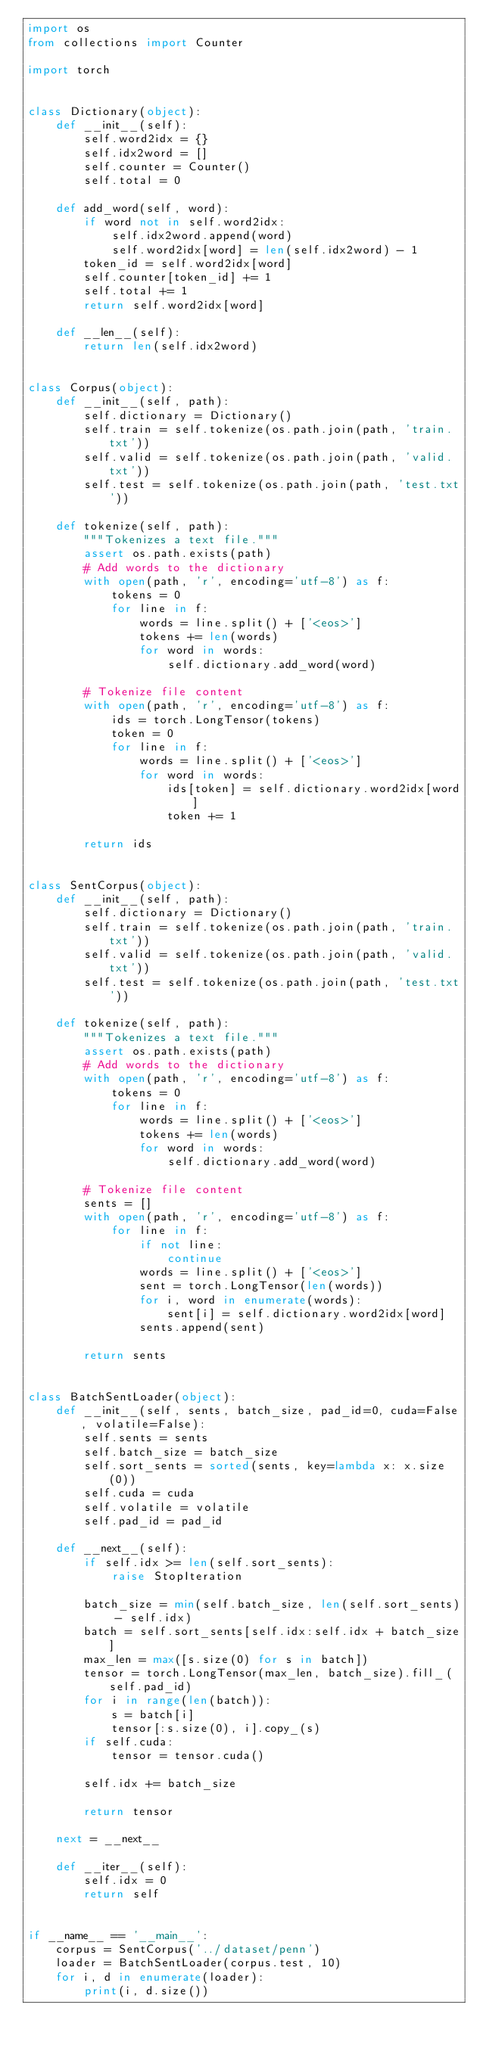Convert code to text. <code><loc_0><loc_0><loc_500><loc_500><_Python_>import os
from collections import Counter

import torch


class Dictionary(object):
    def __init__(self):
        self.word2idx = {}
        self.idx2word = []
        self.counter = Counter()
        self.total = 0

    def add_word(self, word):
        if word not in self.word2idx:
            self.idx2word.append(word)
            self.word2idx[word] = len(self.idx2word) - 1
        token_id = self.word2idx[word]
        self.counter[token_id] += 1
        self.total += 1
        return self.word2idx[word]

    def __len__(self):
        return len(self.idx2word)


class Corpus(object):
    def __init__(self, path):
        self.dictionary = Dictionary()
        self.train = self.tokenize(os.path.join(path, 'train.txt'))
        self.valid = self.tokenize(os.path.join(path, 'valid.txt'))
        self.test = self.tokenize(os.path.join(path, 'test.txt'))

    def tokenize(self, path):
        """Tokenizes a text file."""
        assert os.path.exists(path)
        # Add words to the dictionary
        with open(path, 'r', encoding='utf-8') as f:
            tokens = 0
            for line in f:
                words = line.split() + ['<eos>']
                tokens += len(words)
                for word in words:
                    self.dictionary.add_word(word)

        # Tokenize file content
        with open(path, 'r', encoding='utf-8') as f:
            ids = torch.LongTensor(tokens)
            token = 0
            for line in f:
                words = line.split() + ['<eos>']
                for word in words:
                    ids[token] = self.dictionary.word2idx[word]
                    token += 1

        return ids


class SentCorpus(object):
    def __init__(self, path):
        self.dictionary = Dictionary()
        self.train = self.tokenize(os.path.join(path, 'train.txt'))
        self.valid = self.tokenize(os.path.join(path, 'valid.txt'))
        self.test = self.tokenize(os.path.join(path, 'test.txt'))

    def tokenize(self, path):
        """Tokenizes a text file."""
        assert os.path.exists(path)
        # Add words to the dictionary
        with open(path, 'r', encoding='utf-8') as f:
            tokens = 0
            for line in f:
                words = line.split() + ['<eos>']
                tokens += len(words)
                for word in words:
                    self.dictionary.add_word(word)

        # Tokenize file content
        sents = []
        with open(path, 'r', encoding='utf-8') as f:
            for line in f:
                if not line:
                    continue
                words = line.split() + ['<eos>']
                sent = torch.LongTensor(len(words))
                for i, word in enumerate(words):
                    sent[i] = self.dictionary.word2idx[word]
                sents.append(sent)

        return sents


class BatchSentLoader(object):
    def __init__(self, sents, batch_size, pad_id=0, cuda=False, volatile=False):
        self.sents = sents
        self.batch_size = batch_size
        self.sort_sents = sorted(sents, key=lambda x: x.size(0))
        self.cuda = cuda
        self.volatile = volatile
        self.pad_id = pad_id

    def __next__(self):
        if self.idx >= len(self.sort_sents):
            raise StopIteration

        batch_size = min(self.batch_size, len(self.sort_sents) - self.idx)
        batch = self.sort_sents[self.idx:self.idx + batch_size]
        max_len = max([s.size(0) for s in batch])
        tensor = torch.LongTensor(max_len, batch_size).fill_(self.pad_id)
        for i in range(len(batch)):
            s = batch[i]
            tensor[:s.size(0), i].copy_(s)
        if self.cuda:
            tensor = tensor.cuda()

        self.idx += batch_size

        return tensor

    next = __next__

    def __iter__(self):
        self.idx = 0
        return self


if __name__ == '__main__':
    corpus = SentCorpus('../dataset/penn')
    loader = BatchSentLoader(corpus.test, 10)
    for i, d in enumerate(loader):
        print(i, d.size())
</code> 